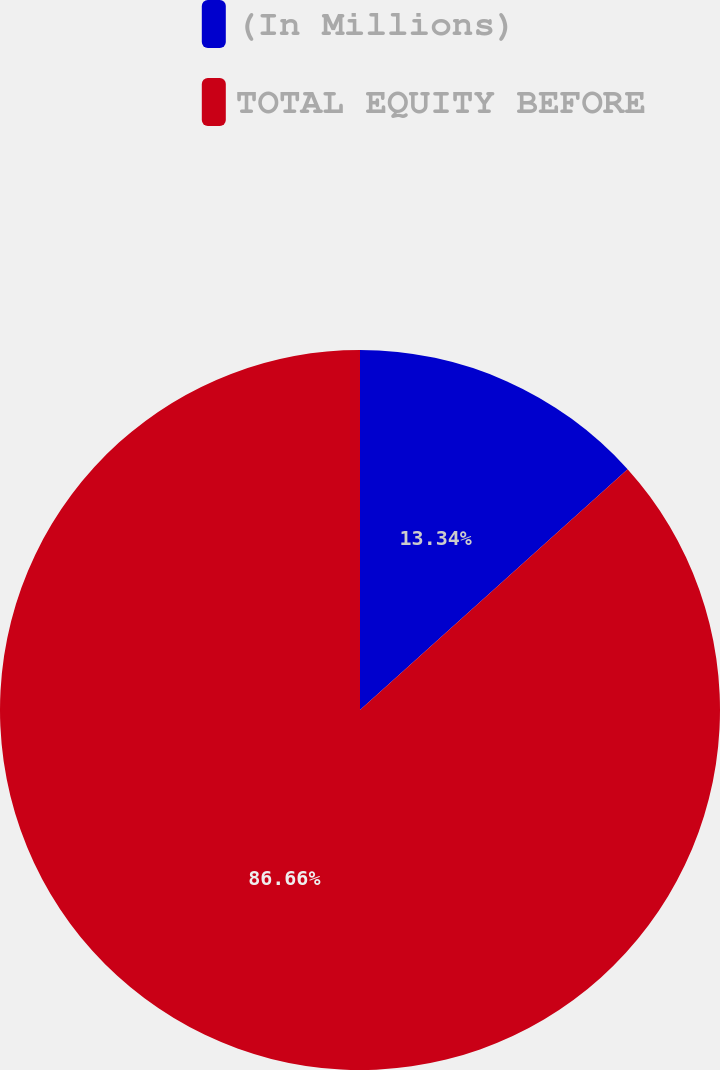<chart> <loc_0><loc_0><loc_500><loc_500><pie_chart><fcel>(In Millions)<fcel>TOTAL EQUITY BEFORE<nl><fcel>13.34%<fcel>86.66%<nl></chart> 